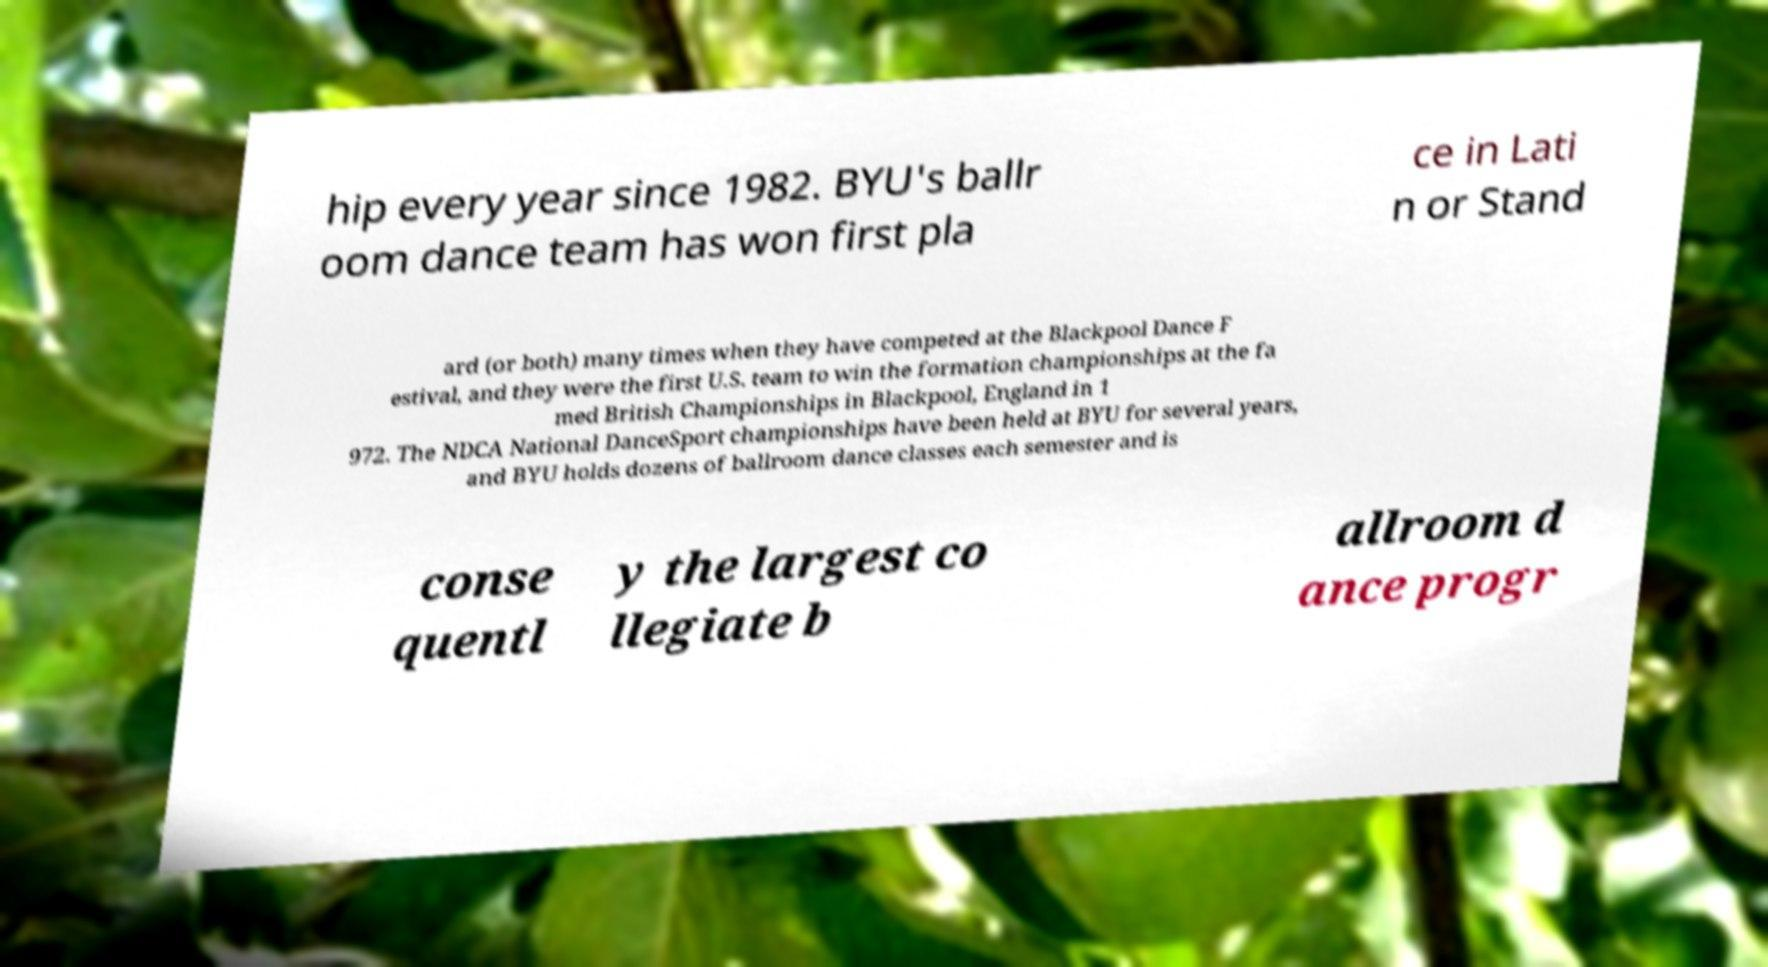Could you assist in decoding the text presented in this image and type it out clearly? hip every year since 1982. BYU's ballr oom dance team has won first pla ce in Lati n or Stand ard (or both) many times when they have competed at the Blackpool Dance F estival, and they were the first U.S. team to win the formation championships at the fa med British Championships in Blackpool, England in 1 972. The NDCA National DanceSport championships have been held at BYU for several years, and BYU holds dozens of ballroom dance classes each semester and is conse quentl y the largest co llegiate b allroom d ance progr 